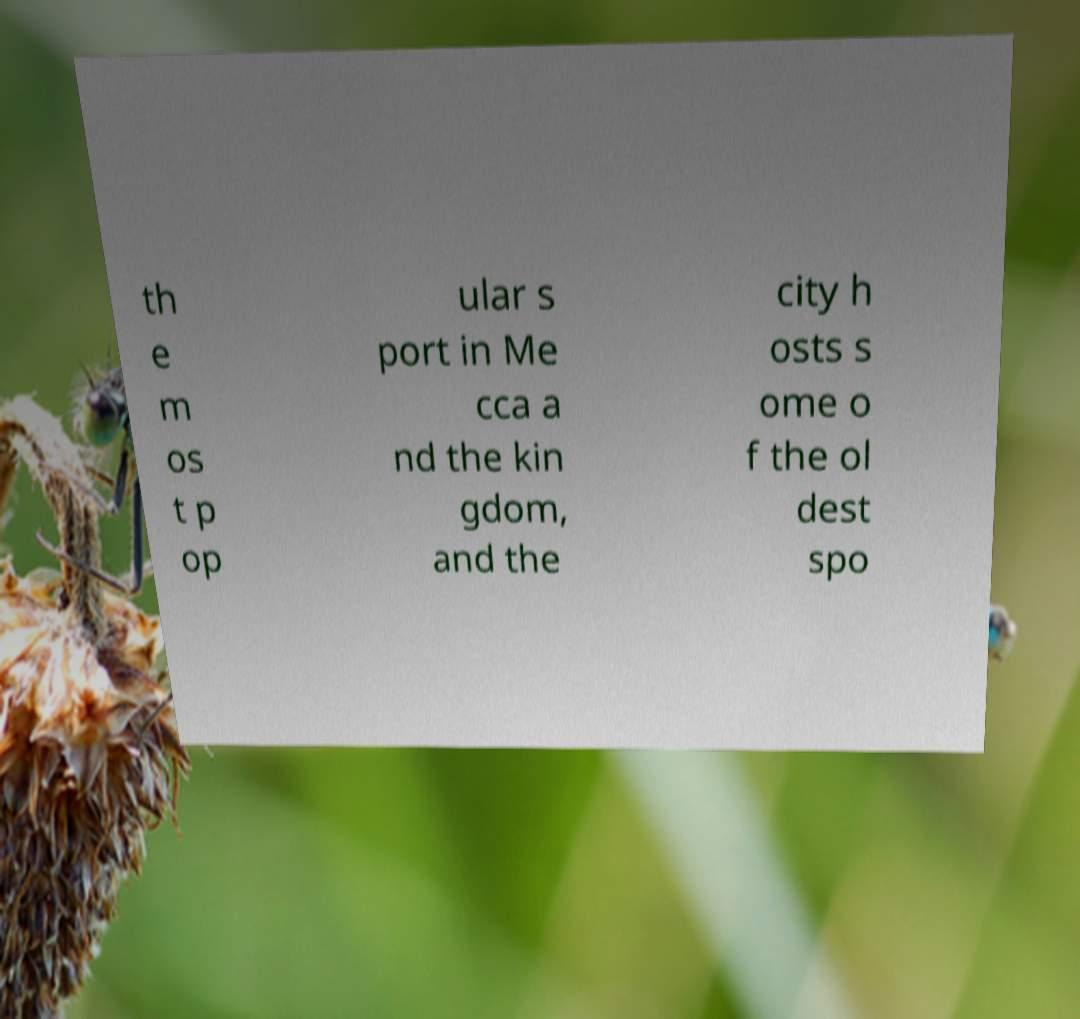Could you extract and type out the text from this image? th e m os t p op ular s port in Me cca a nd the kin gdom, and the city h osts s ome o f the ol dest spo 